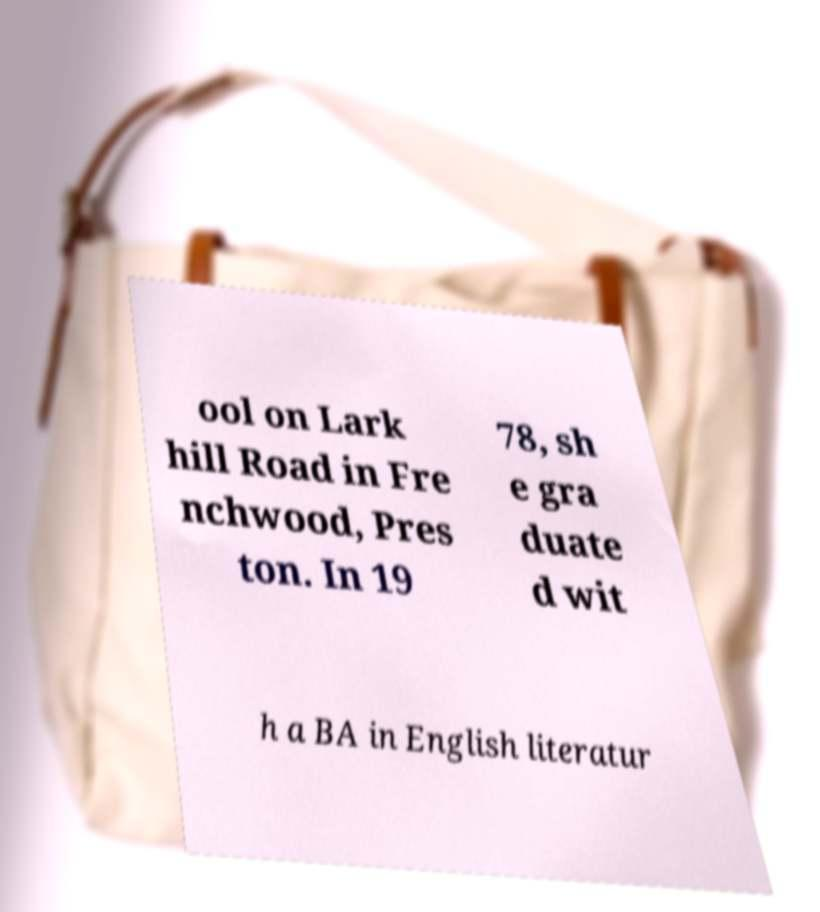Could you extract and type out the text from this image? ool on Lark hill Road in Fre nchwood, Pres ton. In 19 78, sh e gra duate d wit h a BA in English literatur 